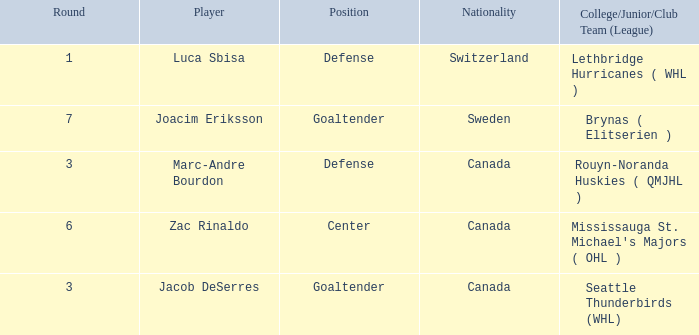What role did luca sbisa perform for the philadelphia flyers? Defense. 